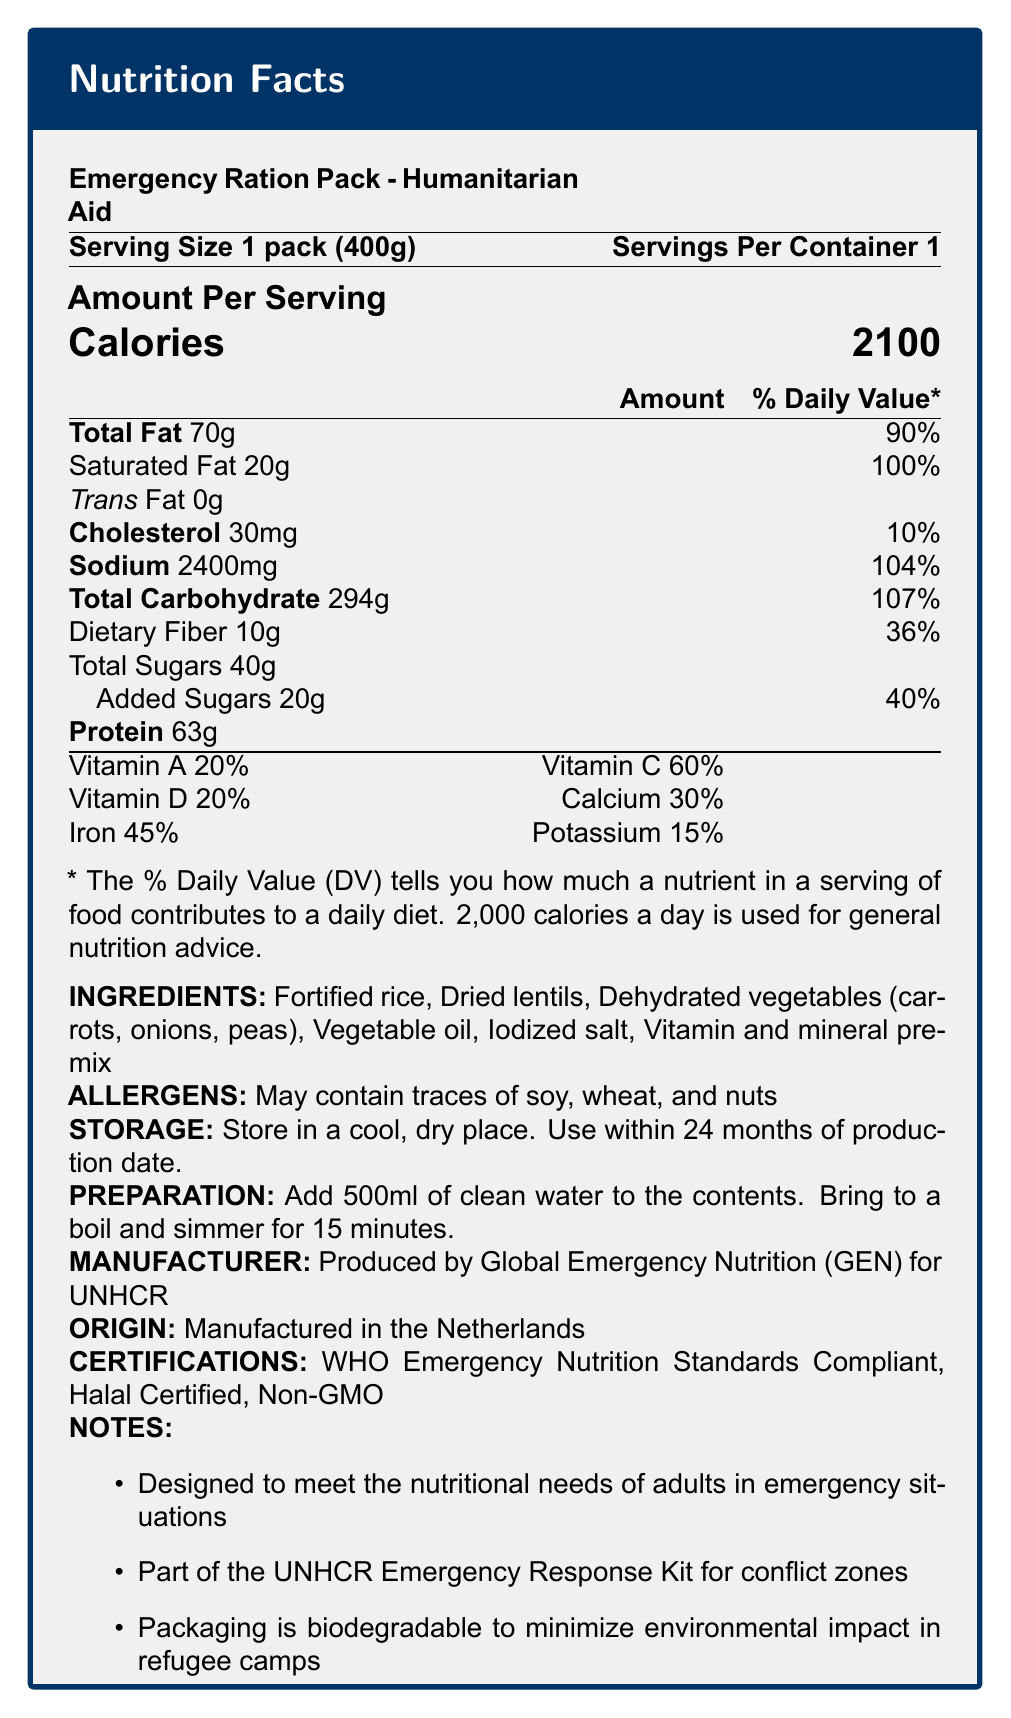what is the serving size of the Emergency Ration Pack? The serving size is clearly listed at the beginning of the document: "Serving Size 1 pack (400g)".
Answer: 1 pack (400g) how many calories are there per serving? The document specifies the calories per serving immediately under the title "Amount Per Serving".
Answer: 2100 what is the source of potassium in the Emergency Ration Pack? The data does not specify where the potassium comes from; it only lists the percentage of the daily value.
Answer: Cannot be determined list three ingredients included in the Emergency Ration Pack. The ingredients are listed under the "INGREDIENTS" section of the document.
Answer: Fortified rice, Dried lentils, Dehydrated vegetables (carrots, onions, peas) what is the daily value percentage of total fat per serving? The document lists the daily value percentage of total fat under the "Amount Per Serving" section.
Answer: 90% what certifications does this product have? These certifications are listed towards the end of the document under the "CERTIFICATIONS" section.
Answer: WHO Emergency Nutrition Standards Compliant, Halal Certified, Non-GMO how should the Emergency Ration Pack be prepared? This is listed under the "PREPARATION" section of the document.
Answer: Add 500ml of clean water to the contents. Bring to a boil and simmer for 15 minutes. what is the manufacturer of the Emergency Ration Pack? A. UNICEF B. World Food Programme C. Global Emergency Nutrition (GEN) D. UNHCR The manufacturer is listed as Global Emergency Nutrition (GEN) under the "MANUFACTURER" section.
Answer: C. Global Emergency Nutrition (GEN) all of the following are found in the Emergency Ration Pack except: A. Dried lentils B. Dehydrated carrots C. Fresh vegetables D. Vegetable oil Fresh vegetables are not listed; only dehydrated vegetables are included.
Answer: C. Fresh vegetables true or false: This product is designed for both adults and children. The document states that the product is "Designed to meet the nutritional needs of adults in emergency situations".
Answer: False summarize the main purpose and contents of the Emergency Ration Pack. The document states the pack's contents, nutritional values, preparation, storage, certifications, and additional relevant notes.
Answer: The Emergency Ration Pack is designed to meet the nutritional needs of adults in emergency situations. It contains fortified rice, dried lentils, dehydrated vegetables, vegetable oil, iodized salt, and a vitamin and mineral premix. It provides 2100 calories per serving, has several certifications, and includes storage and preparation instructions. The pack is part of the UNHCR Emergency Response Kit for conflict zones and has biodegradable packaging to minimize environmental impact in refugee camps. 